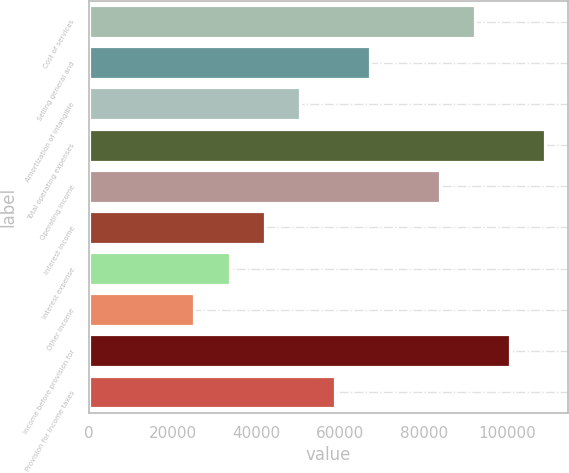<chart> <loc_0><loc_0><loc_500><loc_500><bar_chart><fcel>Cost of services<fcel>Selling general and<fcel>Amortization of intangible<fcel>Total operating expenses<fcel>Operating income<fcel>Interest income<fcel>Interest expense<fcel>Other income<fcel>Income before provision for<fcel>Provision for income taxes<nl><fcel>92289.9<fcel>67120<fcel>50340.1<fcel>109070<fcel>83900<fcel>41950.1<fcel>33560.1<fcel>25170.2<fcel>100680<fcel>58730.1<nl></chart> 